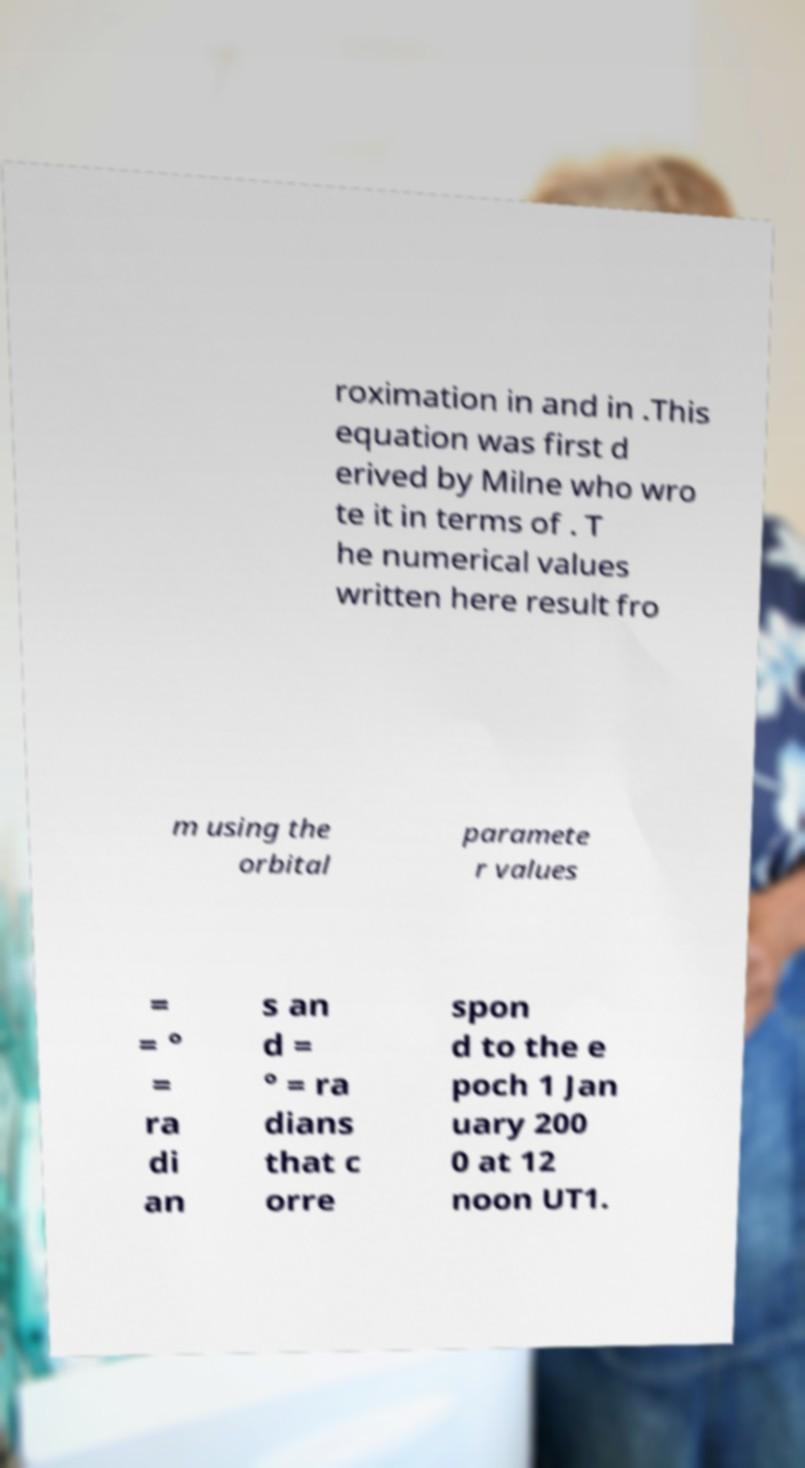Please identify and transcribe the text found in this image. roximation in and in .This equation was first d erived by Milne who wro te it in terms of . T he numerical values written here result fro m using the orbital paramete r values = = ° = ra di an s an d = ° = ra dians that c orre spon d to the e poch 1 Jan uary 200 0 at 12 noon UT1. 